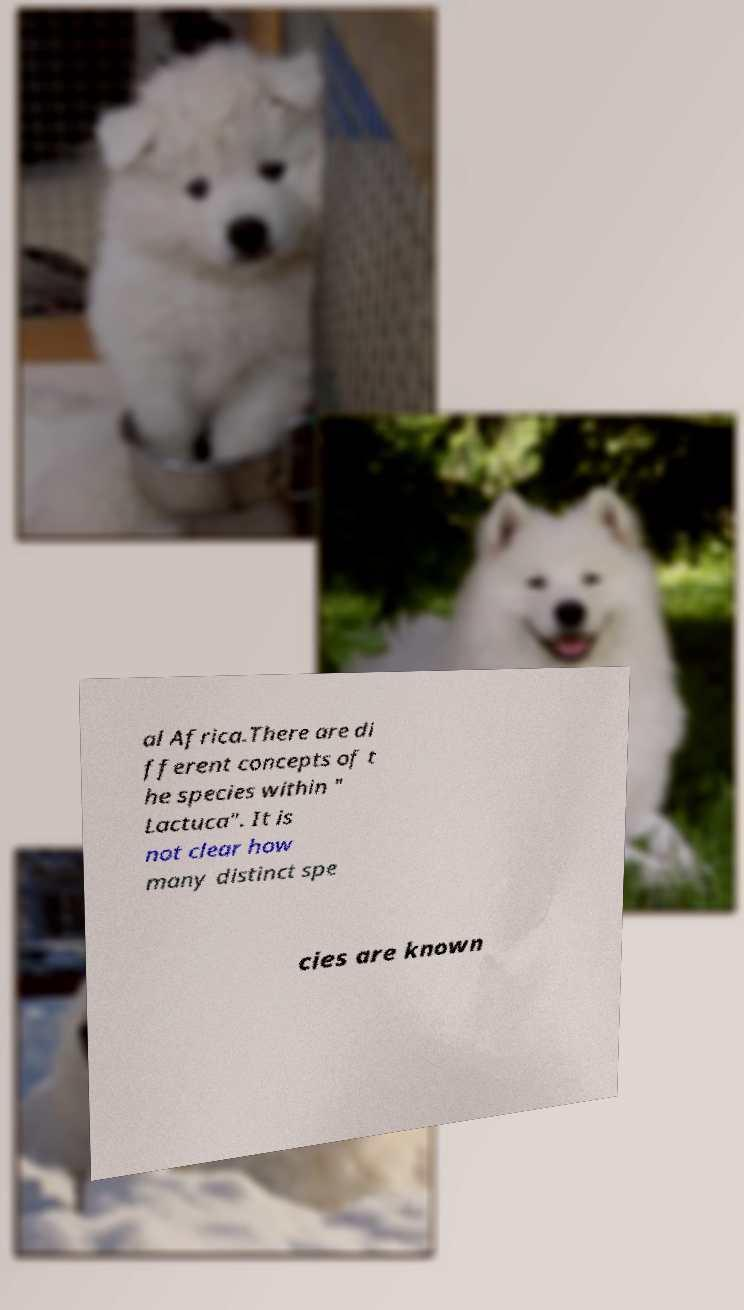I need the written content from this picture converted into text. Can you do that? al Africa.There are di fferent concepts of t he species within " Lactuca". It is not clear how many distinct spe cies are known 